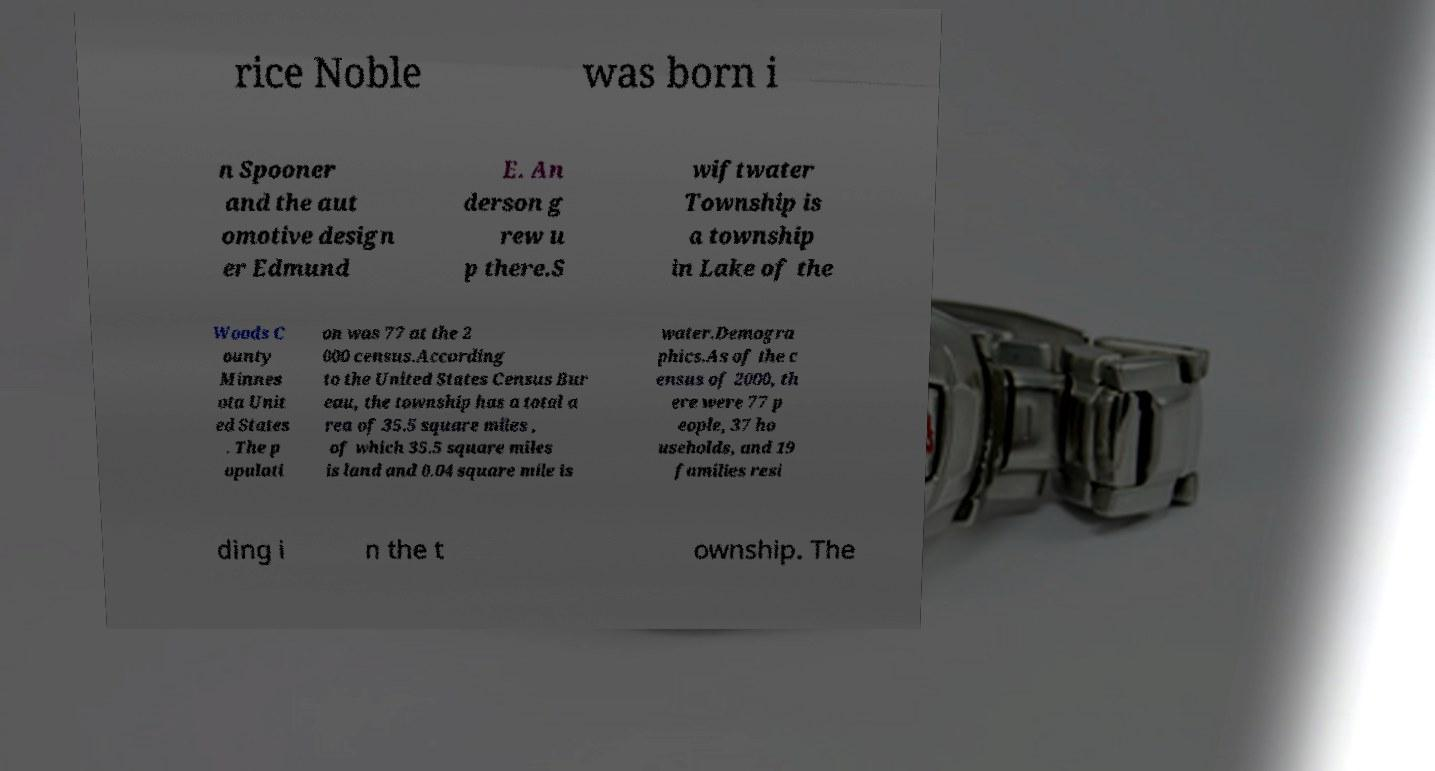Could you assist in decoding the text presented in this image and type it out clearly? rice Noble was born i n Spooner and the aut omotive design er Edmund E. An derson g rew u p there.S wiftwater Township is a township in Lake of the Woods C ounty Minnes ota Unit ed States . The p opulati on was 77 at the 2 000 census.According to the United States Census Bur eau, the township has a total a rea of 35.5 square miles , of which 35.5 square miles is land and 0.04 square mile is water.Demogra phics.As of the c ensus of 2000, th ere were 77 p eople, 37 ho useholds, and 19 families resi ding i n the t ownship. The 